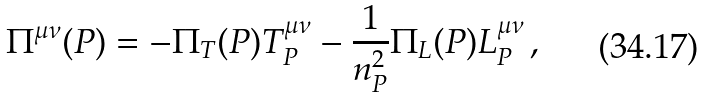<formula> <loc_0><loc_0><loc_500><loc_500>\Pi ^ { \mu \nu } ( P ) = - \Pi _ { T } ( P ) T _ { P } ^ { \mu \nu } - \frac { 1 } { n _ { P } ^ { 2 } } \Pi _ { L } ( P ) L _ { P } ^ { \mu \nu } \, ,</formula> 